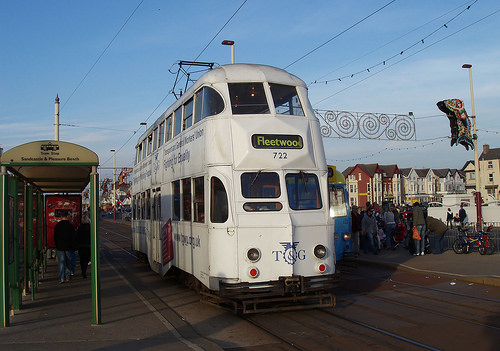<image>
Can you confirm if the wire is to the left of the man? No. The wire is not to the left of the man. From this viewpoint, they have a different horizontal relationship. Is there a bus in the road? Yes. The bus is contained within or inside the road, showing a containment relationship. 